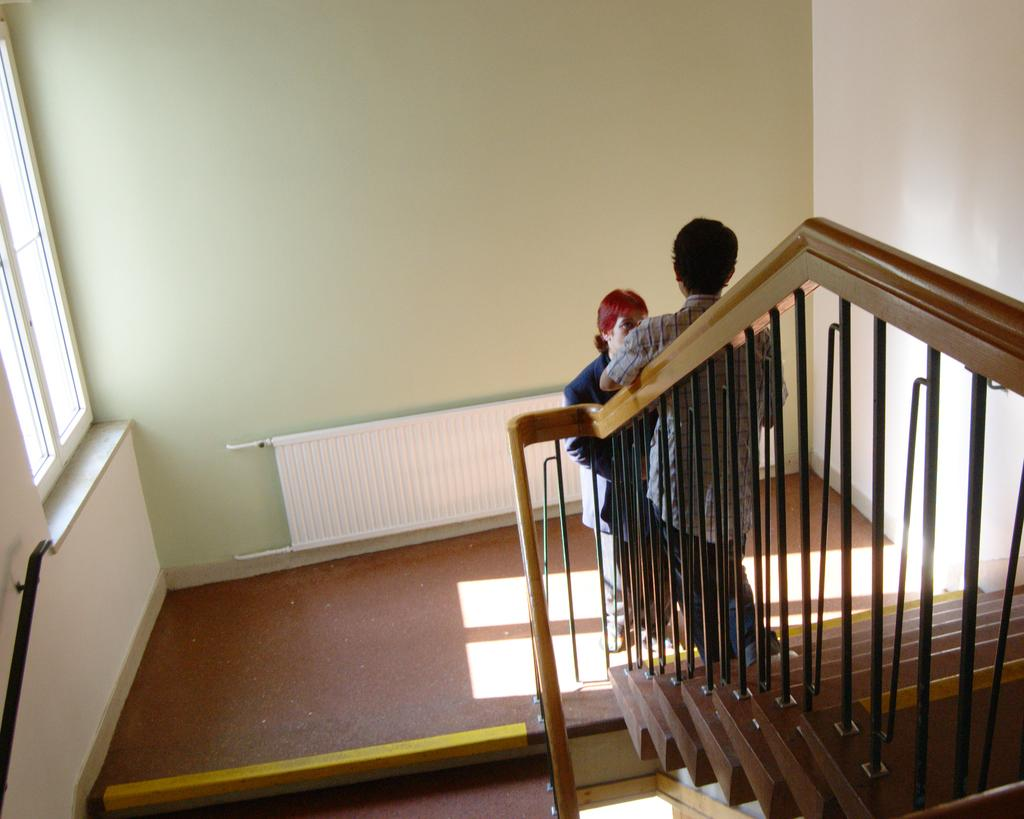How many people are in the image? There are two persons standing on the stairs in the image. Where are the stairs located in the image? The stairs are at the bottom of the image. What can be seen in the background of the image? There is a wall in the background of the image. What architectural feature is visible on the left side of the image? There is a window on the left side of the image. What type of quince is being held by the person on the right side of the image? There is no quince present in the image; it only features two persons standing on the stairs and the surrounding architectural elements. 